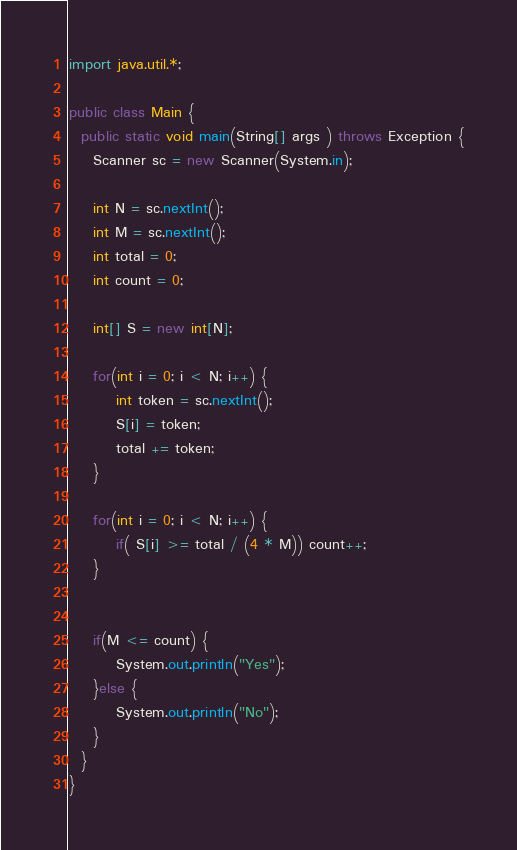<code> <loc_0><loc_0><loc_500><loc_500><_Java_>import java.util.*;

public class Main {
  public static void main(String[] args ) throws Exception {
    Scanner sc = new Scanner(System.in);

    int N = sc.nextInt();
    int M = sc.nextInt();
    int total = 0;
    int count = 0;

    int[] S = new int[N];
    
    for(int i = 0; i < N; i++) {
        int token = sc.nextInt();
        S[i] = token;
        total += token;
    }
    
    for(int i = 0; i < N; i++) {
        if( S[i] >= total / (4 * M)) count++;
    }
    
    
    if(M <= count) {
        System.out.println("Yes");
    }else {
        System.out.println("No");
    }
  }
}
</code> 